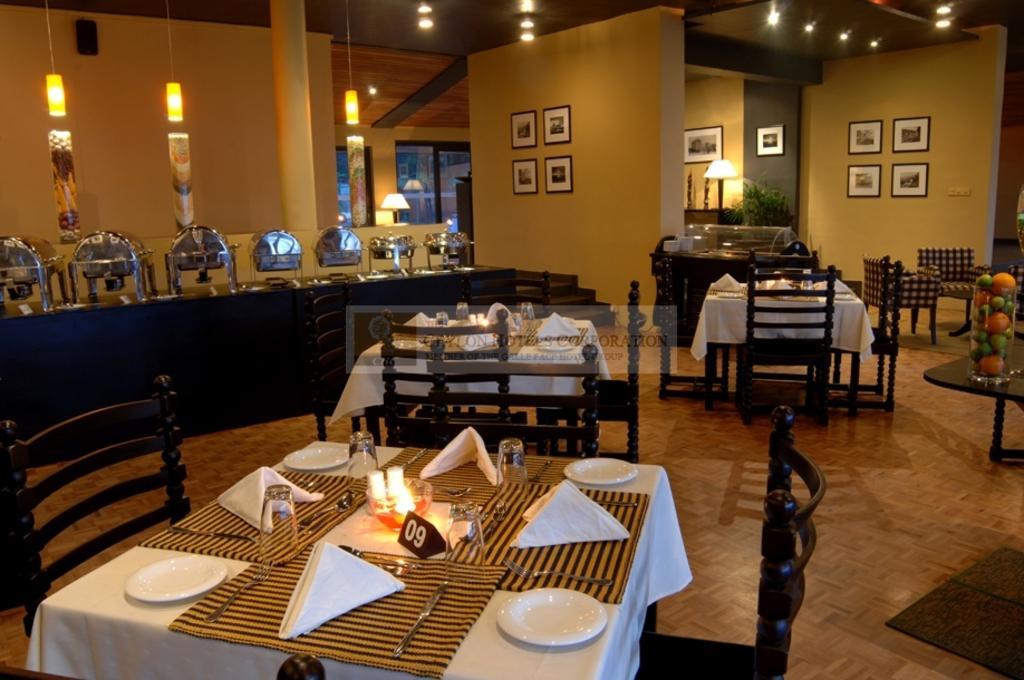Could you give a brief overview of what you see in this image? In this image I can see a table and on the table I can see few clothes, few tissues, few plates, few glasses, few spoons and few candles and I can see few chairs around it. In the background I can see a black colored table and on the table, few chairs, few couches, few walls, few photo frames attached to the walls and few lights. 